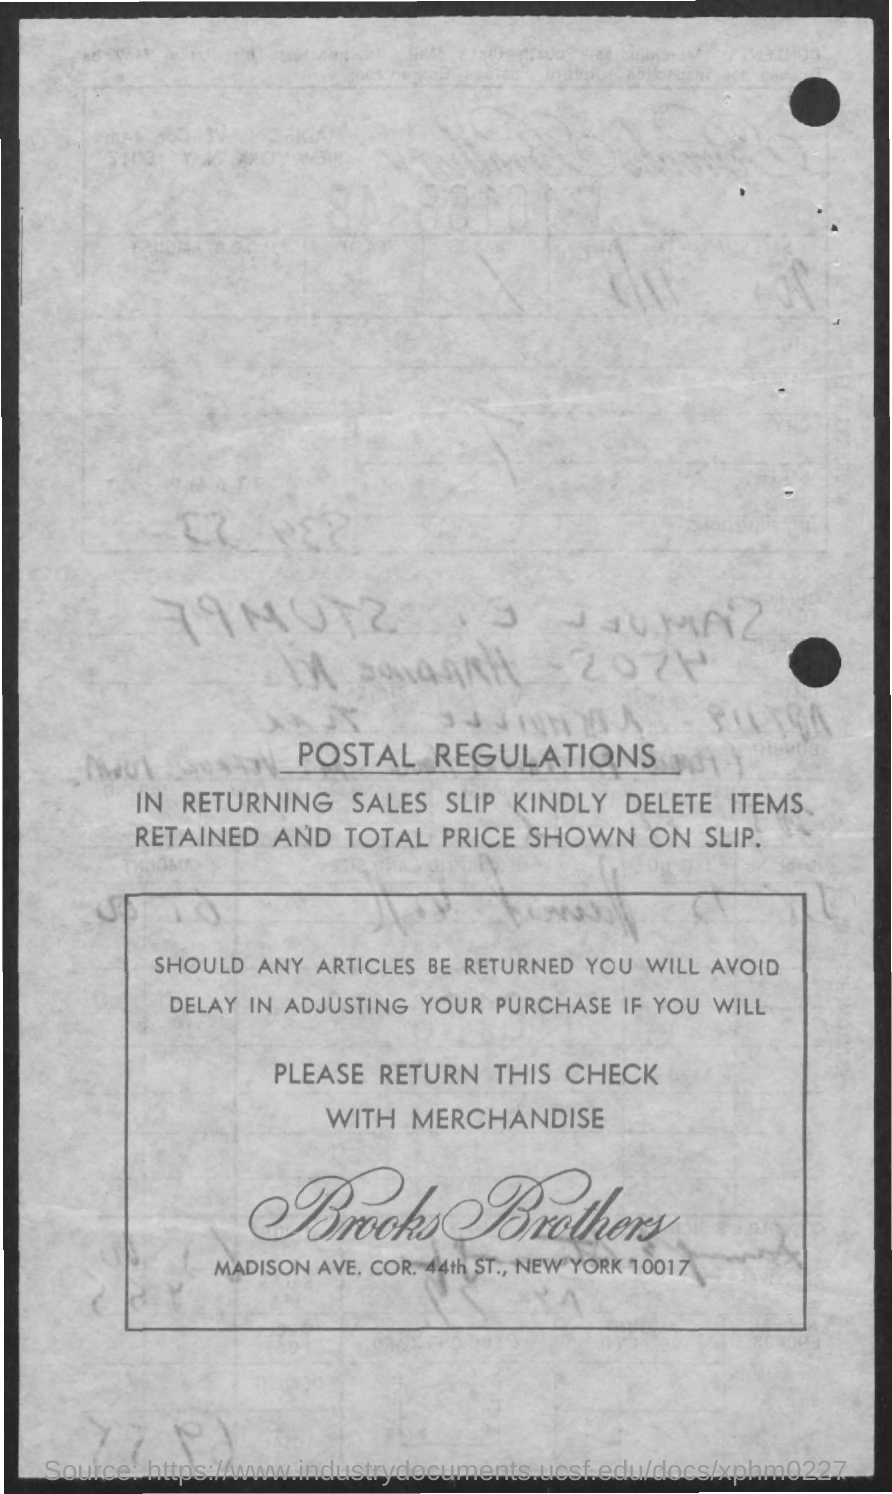What is the first title in the document?
Provide a succinct answer. Postal regulations. What is the name of the company mentioned in the document?
Your response must be concise. Brooks brothers. 